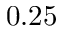Convert formula to latex. <formula><loc_0><loc_0><loc_500><loc_500>0 . 2 5</formula> 